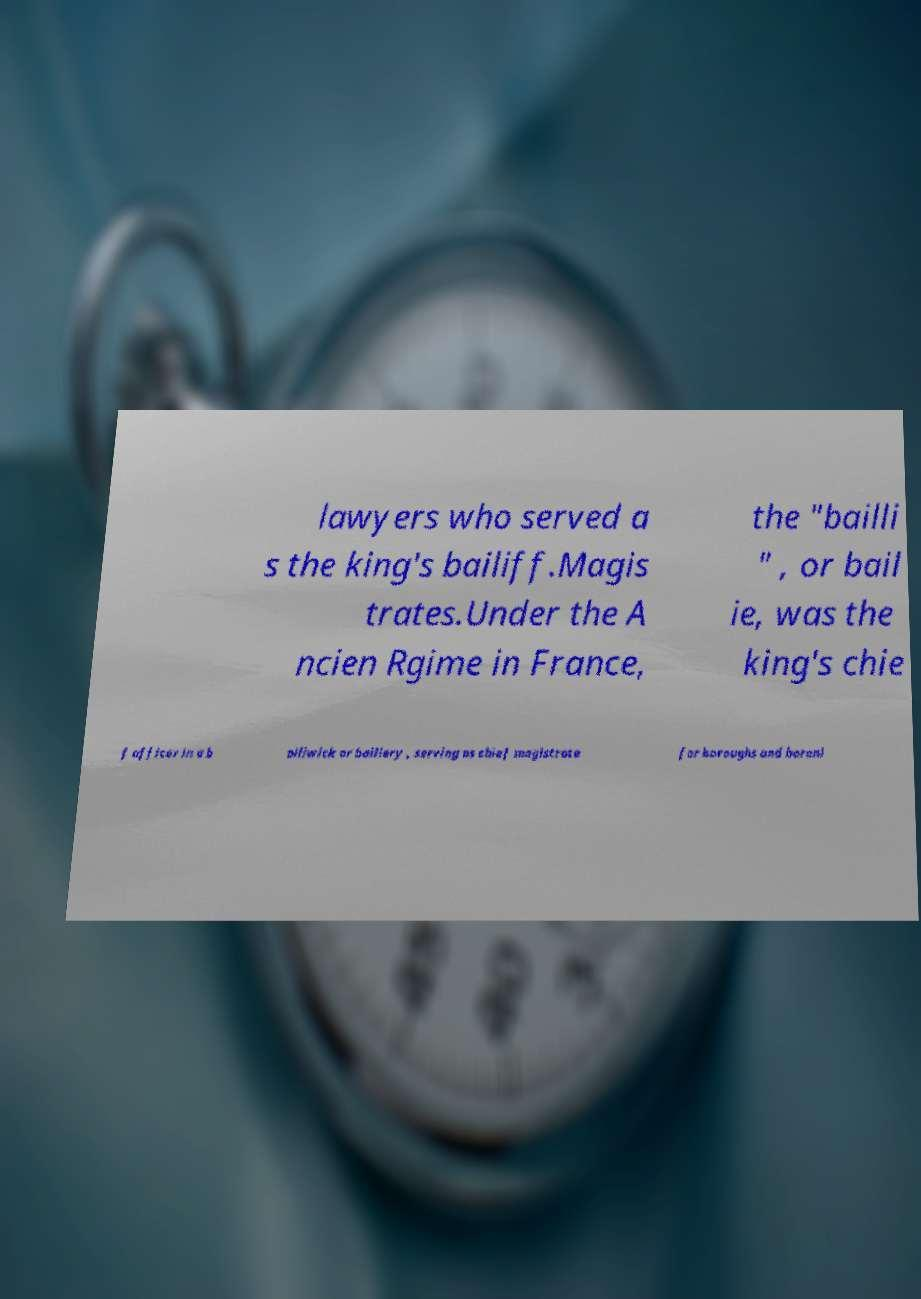There's text embedded in this image that I need extracted. Can you transcribe it verbatim? lawyers who served a s the king's bailiff.Magis trates.Under the A ncien Rgime in France, the "bailli " , or bail ie, was the king's chie f officer in a b ailiwick or bailiery , serving as chief magistrate for boroughs and baroni 